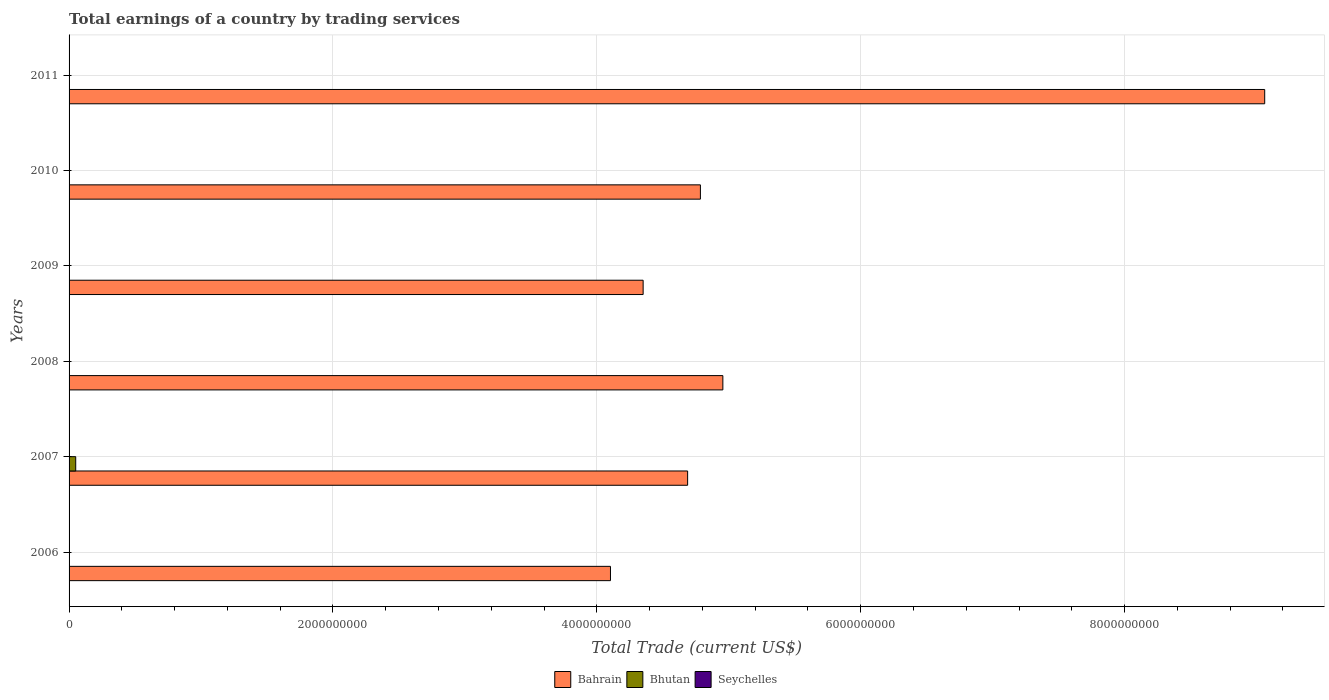How many different coloured bars are there?
Give a very brief answer. 2. Are the number of bars on each tick of the Y-axis equal?
Provide a short and direct response. No. How many bars are there on the 6th tick from the bottom?
Offer a very short reply. 1. In how many cases, is the number of bars for a given year not equal to the number of legend labels?
Your answer should be compact. 6. What is the total earnings in Bahrain in 2007?
Provide a short and direct response. 4.69e+09. Across all years, what is the maximum total earnings in Bhutan?
Keep it short and to the point. 5.04e+07. Across all years, what is the minimum total earnings in Bahrain?
Ensure brevity in your answer.  4.10e+09. In which year was the total earnings in Bahrain maximum?
Your response must be concise. 2011. What is the difference between the total earnings in Bahrain in 2008 and that in 2009?
Provide a short and direct response. 6.04e+08. What is the difference between the total earnings in Seychelles in 2006 and the total earnings in Bahrain in 2008?
Offer a very short reply. -4.96e+09. What is the average total earnings in Bahrain per year?
Your response must be concise. 5.32e+09. What is the ratio of the total earnings in Bahrain in 2007 to that in 2010?
Provide a succinct answer. 0.98. Is the total earnings in Bahrain in 2009 less than that in 2010?
Provide a short and direct response. Yes. What is the difference between the highest and the second highest total earnings in Bahrain?
Provide a succinct answer. 4.11e+09. What is the difference between the highest and the lowest total earnings in Bhutan?
Offer a terse response. 5.04e+07. In how many years, is the total earnings in Bahrain greater than the average total earnings in Bahrain taken over all years?
Give a very brief answer. 1. Is it the case that in every year, the sum of the total earnings in Bahrain and total earnings in Bhutan is greater than the total earnings in Seychelles?
Keep it short and to the point. Yes. Are all the bars in the graph horizontal?
Offer a terse response. Yes. How many years are there in the graph?
Keep it short and to the point. 6. Does the graph contain any zero values?
Offer a terse response. Yes. How many legend labels are there?
Make the answer very short. 3. How are the legend labels stacked?
Offer a terse response. Horizontal. What is the title of the graph?
Provide a short and direct response. Total earnings of a country by trading services. What is the label or title of the X-axis?
Keep it short and to the point. Total Trade (current US$). What is the label or title of the Y-axis?
Offer a very short reply. Years. What is the Total Trade (current US$) in Bahrain in 2006?
Offer a very short reply. 4.10e+09. What is the Total Trade (current US$) of Seychelles in 2006?
Give a very brief answer. 0. What is the Total Trade (current US$) in Bahrain in 2007?
Your answer should be compact. 4.69e+09. What is the Total Trade (current US$) of Bhutan in 2007?
Offer a terse response. 5.04e+07. What is the Total Trade (current US$) of Seychelles in 2007?
Offer a terse response. 0. What is the Total Trade (current US$) in Bahrain in 2008?
Keep it short and to the point. 4.96e+09. What is the Total Trade (current US$) of Bhutan in 2008?
Keep it short and to the point. 0. What is the Total Trade (current US$) in Seychelles in 2008?
Offer a very short reply. 0. What is the Total Trade (current US$) of Bahrain in 2009?
Ensure brevity in your answer.  4.35e+09. What is the Total Trade (current US$) of Bhutan in 2009?
Offer a terse response. 0. What is the Total Trade (current US$) in Bahrain in 2010?
Your answer should be compact. 4.78e+09. What is the Total Trade (current US$) in Bahrain in 2011?
Ensure brevity in your answer.  9.06e+09. Across all years, what is the maximum Total Trade (current US$) of Bahrain?
Your answer should be compact. 9.06e+09. Across all years, what is the maximum Total Trade (current US$) in Bhutan?
Give a very brief answer. 5.04e+07. Across all years, what is the minimum Total Trade (current US$) in Bahrain?
Provide a succinct answer. 4.10e+09. What is the total Total Trade (current US$) in Bahrain in the graph?
Ensure brevity in your answer.  3.19e+1. What is the total Total Trade (current US$) in Bhutan in the graph?
Your answer should be very brief. 5.04e+07. What is the total Total Trade (current US$) of Seychelles in the graph?
Provide a short and direct response. 0. What is the difference between the Total Trade (current US$) in Bahrain in 2006 and that in 2007?
Your response must be concise. -5.85e+08. What is the difference between the Total Trade (current US$) of Bahrain in 2006 and that in 2008?
Provide a succinct answer. -8.52e+08. What is the difference between the Total Trade (current US$) of Bahrain in 2006 and that in 2009?
Your answer should be compact. -2.48e+08. What is the difference between the Total Trade (current US$) in Bahrain in 2006 and that in 2010?
Provide a short and direct response. -6.82e+08. What is the difference between the Total Trade (current US$) in Bahrain in 2006 and that in 2011?
Your answer should be compact. -4.96e+09. What is the difference between the Total Trade (current US$) of Bahrain in 2007 and that in 2008?
Provide a short and direct response. -2.67e+08. What is the difference between the Total Trade (current US$) of Bahrain in 2007 and that in 2009?
Keep it short and to the point. 3.37e+08. What is the difference between the Total Trade (current US$) in Bahrain in 2007 and that in 2010?
Offer a very short reply. -9.68e+07. What is the difference between the Total Trade (current US$) in Bahrain in 2007 and that in 2011?
Provide a succinct answer. -4.37e+09. What is the difference between the Total Trade (current US$) in Bahrain in 2008 and that in 2009?
Provide a short and direct response. 6.04e+08. What is the difference between the Total Trade (current US$) in Bahrain in 2008 and that in 2010?
Give a very brief answer. 1.70e+08. What is the difference between the Total Trade (current US$) in Bahrain in 2008 and that in 2011?
Offer a terse response. -4.11e+09. What is the difference between the Total Trade (current US$) of Bahrain in 2009 and that in 2010?
Offer a very short reply. -4.34e+08. What is the difference between the Total Trade (current US$) of Bahrain in 2009 and that in 2011?
Provide a short and direct response. -4.71e+09. What is the difference between the Total Trade (current US$) in Bahrain in 2010 and that in 2011?
Your answer should be compact. -4.28e+09. What is the difference between the Total Trade (current US$) in Bahrain in 2006 and the Total Trade (current US$) in Bhutan in 2007?
Offer a terse response. 4.05e+09. What is the average Total Trade (current US$) in Bahrain per year?
Provide a short and direct response. 5.32e+09. What is the average Total Trade (current US$) in Bhutan per year?
Ensure brevity in your answer.  8.40e+06. In the year 2007, what is the difference between the Total Trade (current US$) in Bahrain and Total Trade (current US$) in Bhutan?
Your response must be concise. 4.64e+09. What is the ratio of the Total Trade (current US$) in Bahrain in 2006 to that in 2007?
Make the answer very short. 0.88. What is the ratio of the Total Trade (current US$) in Bahrain in 2006 to that in 2008?
Offer a very short reply. 0.83. What is the ratio of the Total Trade (current US$) in Bahrain in 2006 to that in 2009?
Your answer should be compact. 0.94. What is the ratio of the Total Trade (current US$) of Bahrain in 2006 to that in 2010?
Provide a succinct answer. 0.86. What is the ratio of the Total Trade (current US$) of Bahrain in 2006 to that in 2011?
Make the answer very short. 0.45. What is the ratio of the Total Trade (current US$) in Bahrain in 2007 to that in 2008?
Give a very brief answer. 0.95. What is the ratio of the Total Trade (current US$) in Bahrain in 2007 to that in 2009?
Give a very brief answer. 1.08. What is the ratio of the Total Trade (current US$) of Bahrain in 2007 to that in 2010?
Keep it short and to the point. 0.98. What is the ratio of the Total Trade (current US$) in Bahrain in 2007 to that in 2011?
Your answer should be very brief. 0.52. What is the ratio of the Total Trade (current US$) of Bahrain in 2008 to that in 2009?
Your answer should be compact. 1.14. What is the ratio of the Total Trade (current US$) in Bahrain in 2008 to that in 2010?
Your response must be concise. 1.04. What is the ratio of the Total Trade (current US$) in Bahrain in 2008 to that in 2011?
Make the answer very short. 0.55. What is the ratio of the Total Trade (current US$) in Bahrain in 2009 to that in 2010?
Offer a very short reply. 0.91. What is the ratio of the Total Trade (current US$) in Bahrain in 2009 to that in 2011?
Make the answer very short. 0.48. What is the ratio of the Total Trade (current US$) of Bahrain in 2010 to that in 2011?
Offer a very short reply. 0.53. What is the difference between the highest and the second highest Total Trade (current US$) of Bahrain?
Your answer should be very brief. 4.11e+09. What is the difference between the highest and the lowest Total Trade (current US$) in Bahrain?
Your response must be concise. 4.96e+09. What is the difference between the highest and the lowest Total Trade (current US$) of Bhutan?
Make the answer very short. 5.04e+07. 